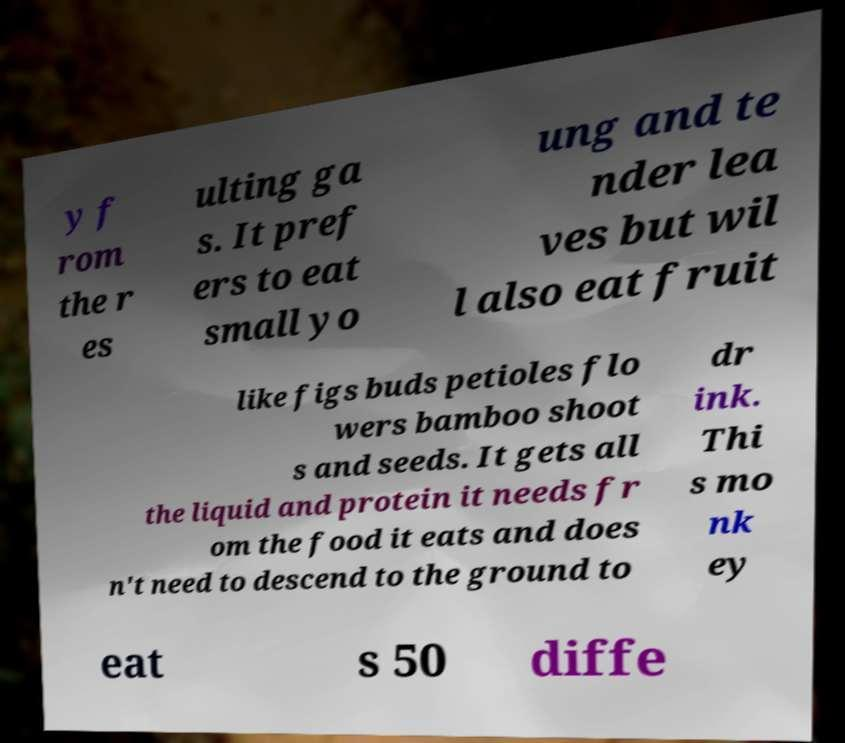Could you extract and type out the text from this image? y f rom the r es ulting ga s. It pref ers to eat small yo ung and te nder lea ves but wil l also eat fruit like figs buds petioles flo wers bamboo shoot s and seeds. It gets all the liquid and protein it needs fr om the food it eats and does n't need to descend to the ground to dr ink. Thi s mo nk ey eat s 50 diffe 